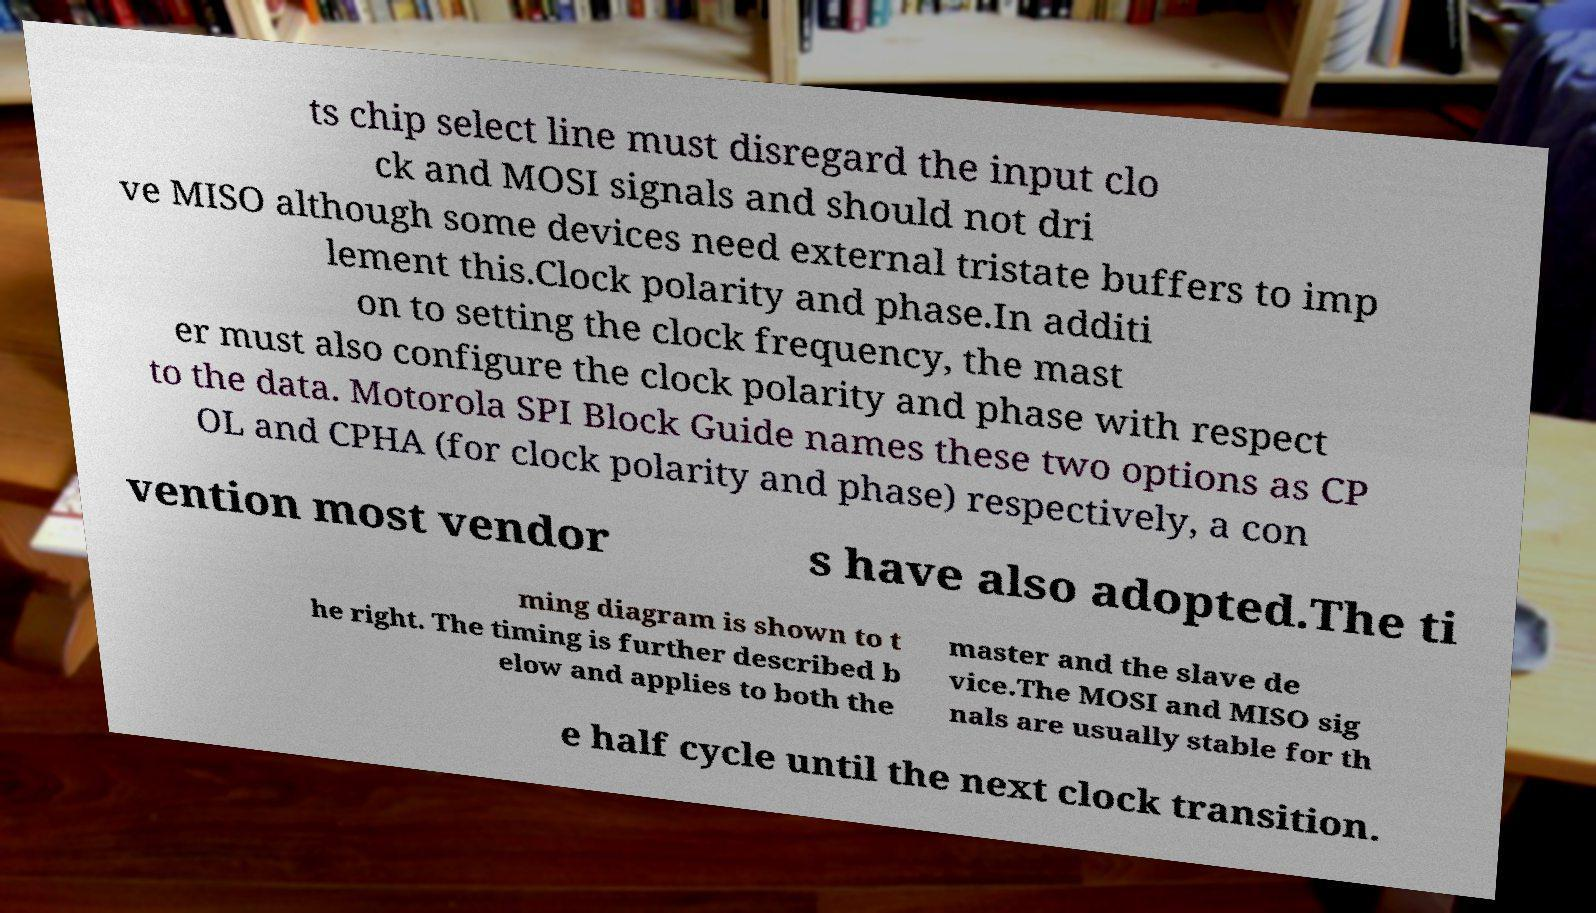Can you read and provide the text displayed in the image?This photo seems to have some interesting text. Can you extract and type it out for me? ts chip select line must disregard the input clo ck and MOSI signals and should not dri ve MISO although some devices need external tristate buffers to imp lement this.Clock polarity and phase.In additi on to setting the clock frequency, the mast er must also configure the clock polarity and phase with respect to the data. Motorola SPI Block Guide names these two options as CP OL and CPHA (for clock polarity and phase) respectively, a con vention most vendor s have also adopted.The ti ming diagram is shown to t he right. The timing is further described b elow and applies to both the master and the slave de vice.The MOSI and MISO sig nals are usually stable for th e half cycle until the next clock transition. 